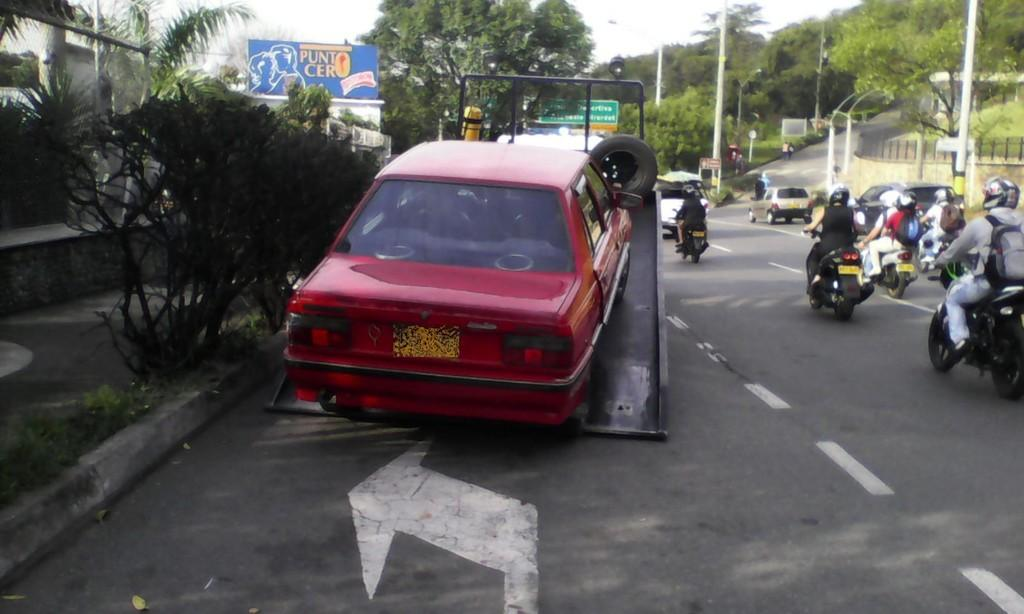What type of vehicle is in the image? There is a red color car in the image. What other mode of transportation can be seen in the image? There is a motorcycle in the image. What type of street furniture is present in the image? There are street lamps in the image. What additional feature is present in the image? There is a banner in the image. What type of barrier is visible in the image? There is a fence in the image. What is visible at the top of the image? The sky is visible at the top of the image. Can you tell me how many pickles are on the motorcycle in the image? There are no pickles present in the image; it features a car, a motorcycle, street lamps, a banner, a fence, and a visible sky. What type of pig can be seen interacting with the car in the image? There is no pig present in the image; it only features a car, a motorcycle, street lamps, a banner, a fence, and a visible sky. 